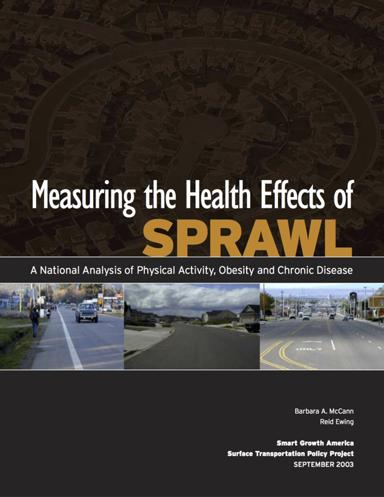How does urban sprawl relate to obesity and chronic diseases according to the brochure's analysis? According to the brochure, urban sprawl contributes to lower physical activity levels due to increased reliance on vehicle transportation rather than walking or biking. This decrease in physical activity can lead to higher obesity rates and a rise in related chronic diseases like hypertension and diabetes. 